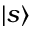Convert formula to latex. <formula><loc_0><loc_0><loc_500><loc_500>{ \left | s \right \rangle }</formula> 